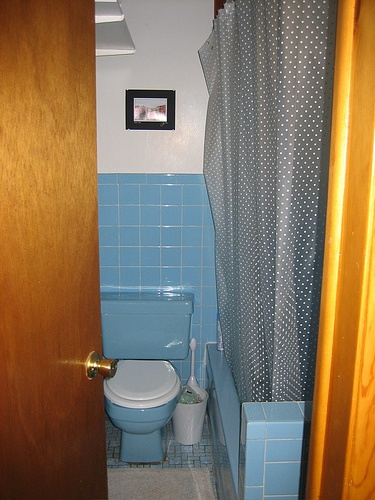Describe the objects in this image and their specific colors. I can see a toilet in maroon, gray, and darkgray tones in this image. 